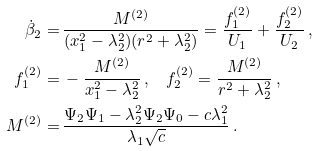<formula> <loc_0><loc_0><loc_500><loc_500>\dot { \beta } _ { 2 } = & \, \frac { M ^ { ( 2 ) } } { ( x _ { 1 } ^ { 2 } - \lambda _ { 2 } ^ { 2 } ) ( r ^ { 2 } + \lambda _ { 2 } ^ { 2 } ) } = \frac { f _ { 1 } ^ { ( 2 ) } } { U _ { 1 } } + \frac { f _ { 2 } ^ { ( 2 ) } } { U _ { 2 } } \, , \\ f _ { 1 } ^ { ( 2 ) } = & \, - \frac { M ^ { ( 2 ) } } { x _ { 1 } ^ { 2 } - \lambda _ { 2 } ^ { 2 } } \, , \quad f _ { 2 } ^ { ( 2 ) } = \frac { M ^ { ( 2 ) } } { r ^ { 2 } + \lambda _ { 2 } ^ { 2 } } \, , \\ M ^ { ( 2 ) } = & \, \frac { \Psi _ { 2 } \Psi _ { 1 } - \lambda _ { 2 } ^ { 2 } \Psi _ { 2 } \Psi _ { 0 } - c \lambda _ { 1 } ^ { 2 } } { \lambda _ { 1 } \sqrt { c } } \, .</formula> 